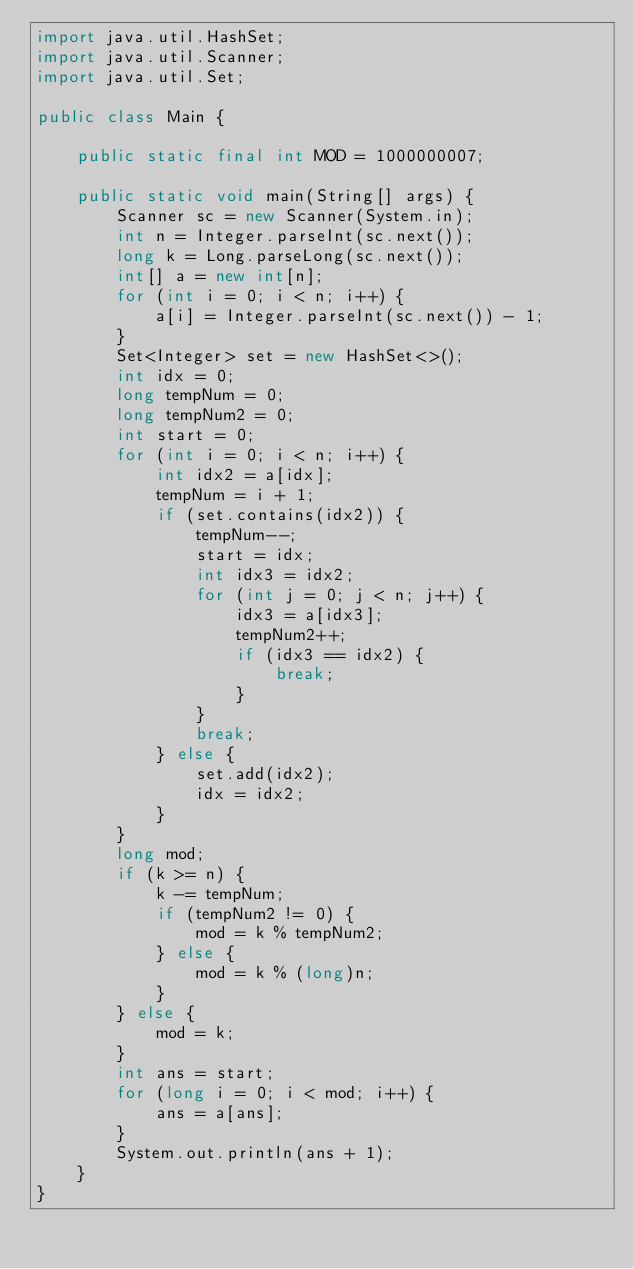<code> <loc_0><loc_0><loc_500><loc_500><_Java_>import java.util.HashSet;
import java.util.Scanner;
import java.util.Set;

public class Main {

    public static final int MOD = 1000000007;

    public static void main(String[] args) {
        Scanner sc = new Scanner(System.in);
        int n = Integer.parseInt(sc.next());
        long k = Long.parseLong(sc.next());
        int[] a = new int[n];
        for (int i = 0; i < n; i++) {
            a[i] = Integer.parseInt(sc.next()) - 1;
        }
        Set<Integer> set = new HashSet<>();
        int idx = 0;
        long tempNum = 0;
        long tempNum2 = 0;
        int start = 0;
        for (int i = 0; i < n; i++) {
            int idx2 = a[idx];
            tempNum = i + 1;
            if (set.contains(idx2)) {
                tempNum--;
                start = idx;
                int idx3 = idx2;
                for (int j = 0; j < n; j++) {
                    idx3 = a[idx3];
                    tempNum2++;
                    if (idx3 == idx2) {
                        break;
                    }
                }
                break;
            } else {
                set.add(idx2);
                idx = idx2;
            }
        }
        long mod;
        if (k >= n) {
            k -= tempNum;
            if (tempNum2 != 0) {
                mod = k % tempNum2;
            } else {
                mod = k % (long)n;
            }
        } else {
            mod = k;
        }
        int ans = start;
        for (long i = 0; i < mod; i++) {
            ans = a[ans];
        }
        System.out.println(ans + 1);
    }
}</code> 